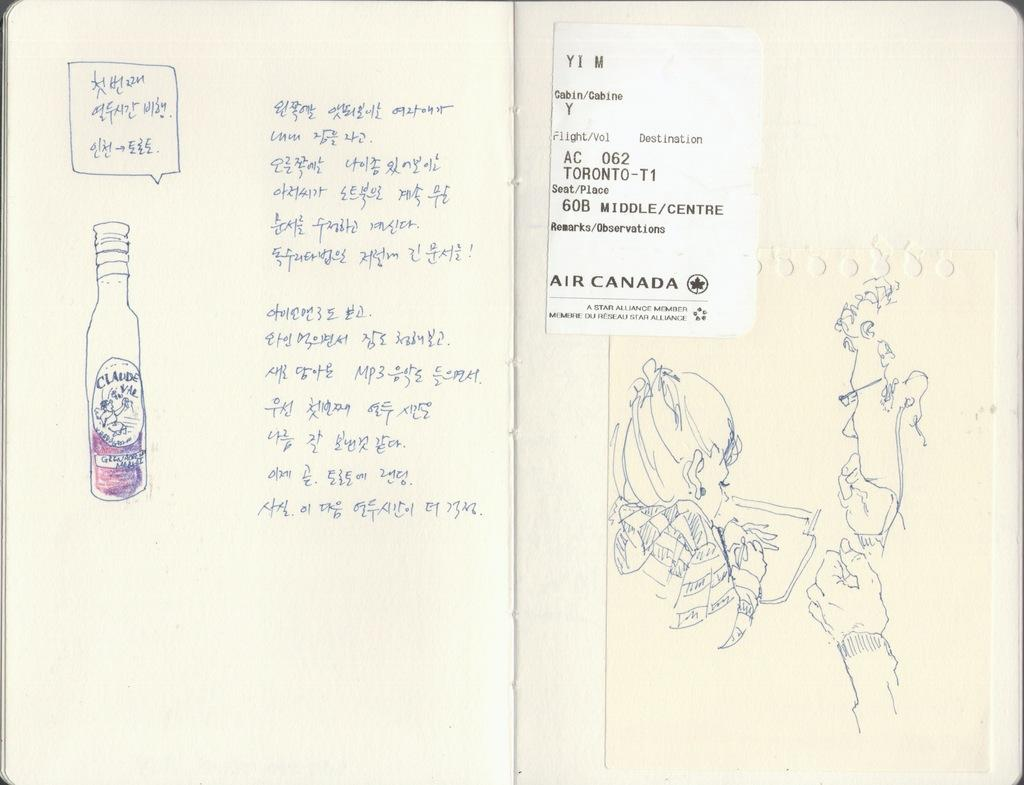<image>
Create a compact narrative representing the image presented. A picture is on the wall showing an equation 